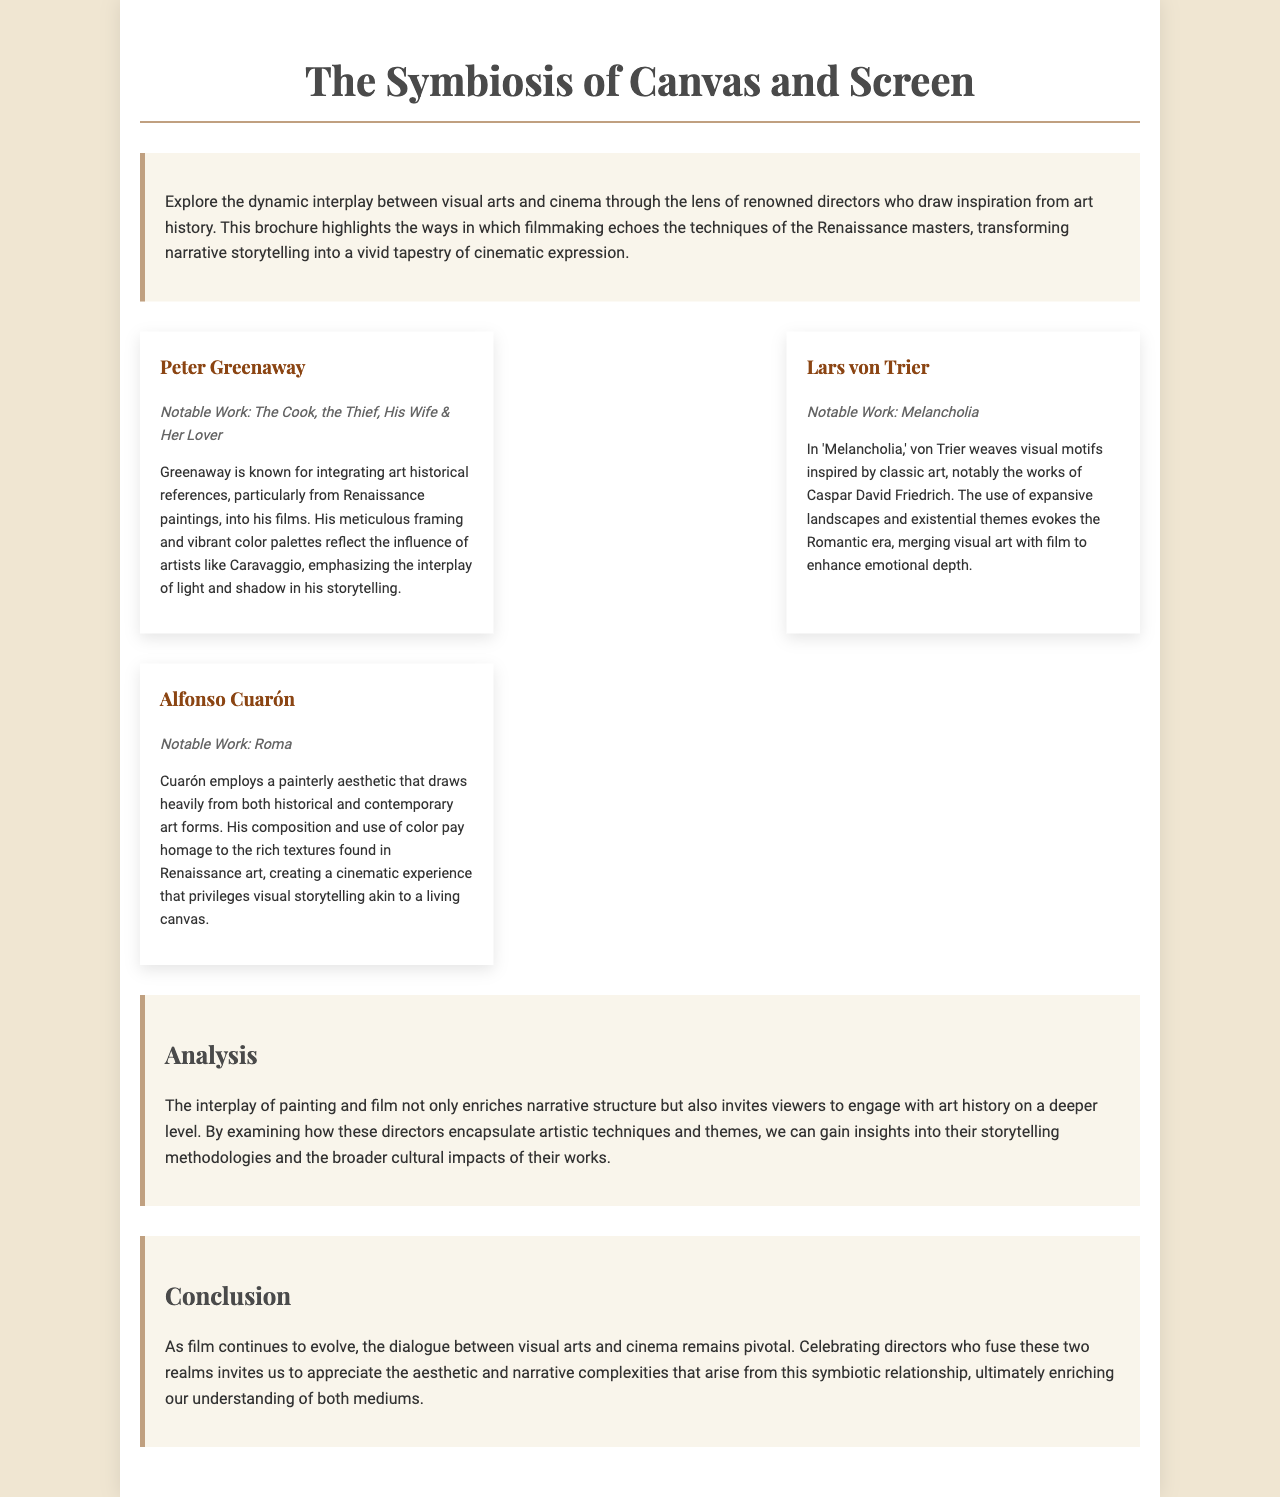what is the title of the brochure? The title of the brochure is stated at the top and serves as the primary subject of the document.
Answer: The Symbiosis of Canvas and Screen who is the director associated with the notable work "Melancholia"? The document explicitly mentions directors along with their notable works, making it straightforward to identify them.
Answer: Lars von Trier which director integrates art historical references from Renaissance paintings? The text highlights specific attributes of each director, indicating their influences and styles.
Answer: Peter Greenaway how does Alfonso Cuarón create a cinematic experience? This involves synthesizing information about his stylistic choices as explained in the brochure.
Answer: Painterly aesthetic name one artist whose work influenced Peter Greenaway. The document attributes specific artistic inspirations to each director, detailing their unique styles.
Answer: Caravaggio what theme does Lars von Trier explore in his work? The reasoning involves understanding the emotional and thematic layers presented in the description of his film.
Answer: Existential themes how does the brochure describe the relationship between painting and film? This relates to a broader understanding presented in the analysis section of the document that connects the two mediums.
Answer: Enriches narrative structure what is the overall purpose of the brochure? The introduction provides context and motivation for the content presented in the document, summarizing its intent.
Answer: Celebrate directors who incorporate art historical narratives 